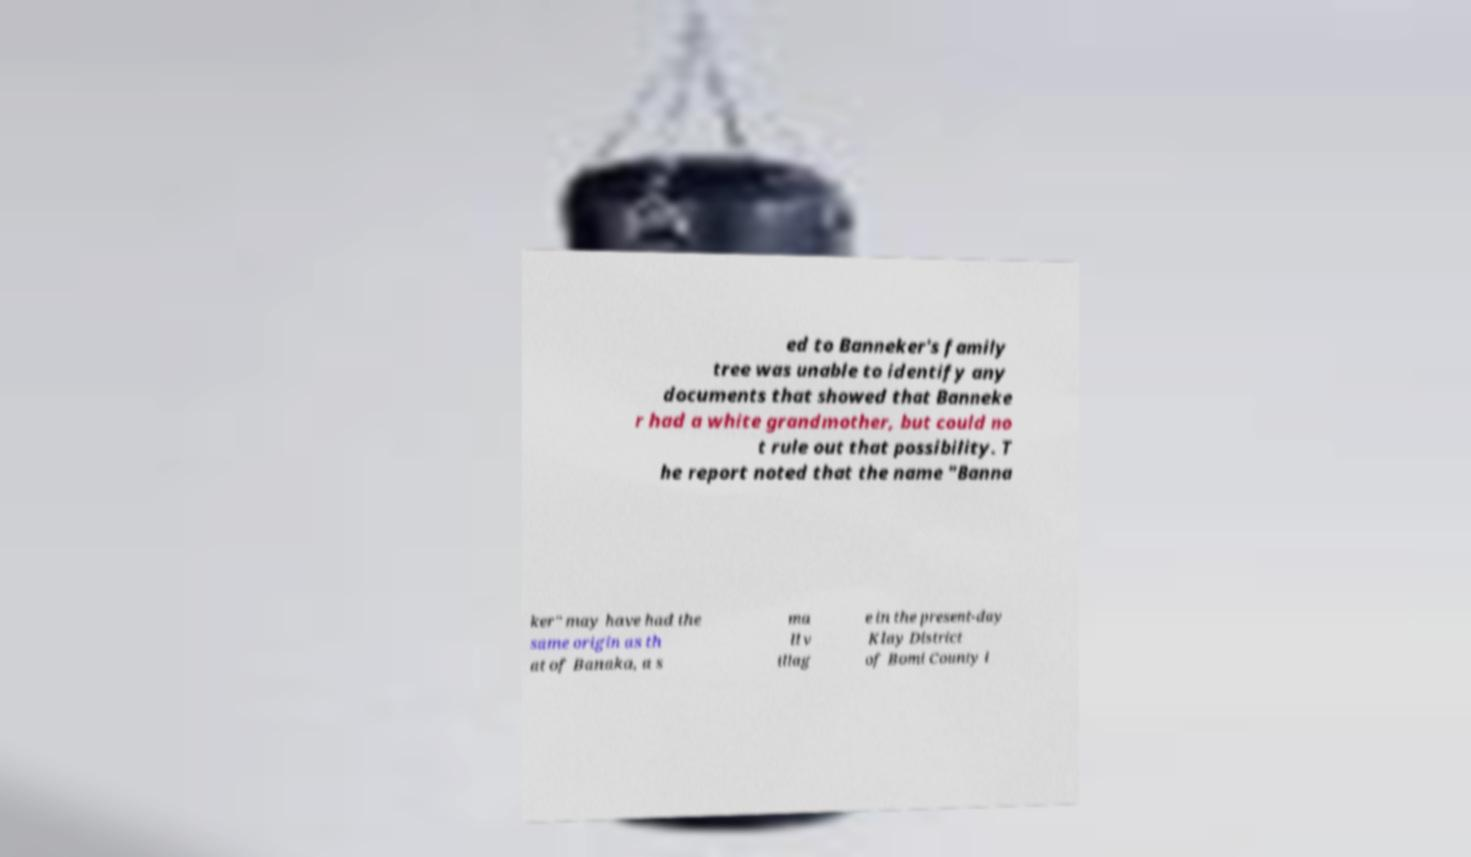Could you assist in decoding the text presented in this image and type it out clearly? ed to Banneker's family tree was unable to identify any documents that showed that Banneke r had a white grandmother, but could no t rule out that possibility. T he report noted that the name "Banna ker" may have had the same origin as th at of Banaka, a s ma ll v illag e in the present-day Klay District of Bomi County i 